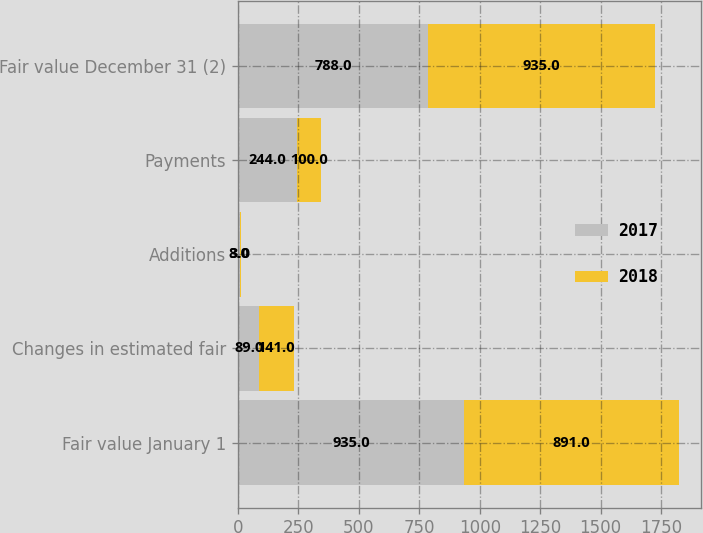Convert chart. <chart><loc_0><loc_0><loc_500><loc_500><stacked_bar_chart><ecel><fcel>Fair value January 1<fcel>Changes in estimated fair<fcel>Additions<fcel>Payments<fcel>Fair value December 31 (2)<nl><fcel>2017<fcel>935<fcel>89<fcel>8<fcel>244<fcel>788<nl><fcel>2018<fcel>891<fcel>141<fcel>3<fcel>100<fcel>935<nl></chart> 